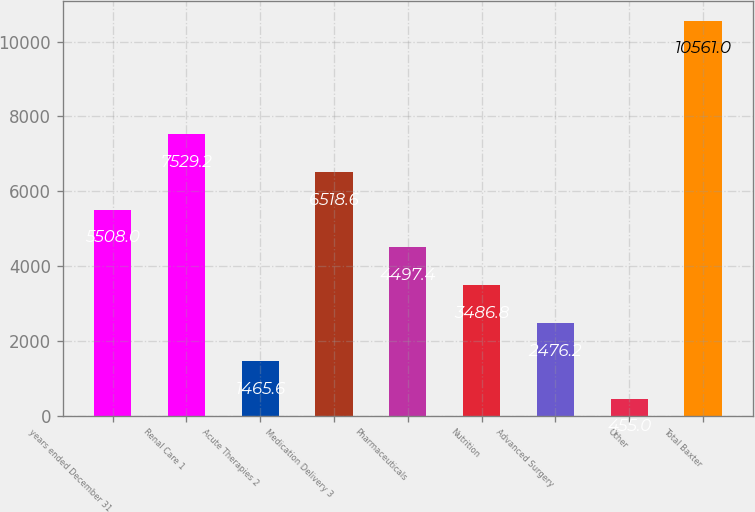Convert chart. <chart><loc_0><loc_0><loc_500><loc_500><bar_chart><fcel>years ended December 31<fcel>Renal Care 1<fcel>Acute Therapies 2<fcel>Medication Delivery 3<fcel>Pharmaceuticals<fcel>Nutrition<fcel>Advanced Surgery<fcel>Other<fcel>Total Baxter<nl><fcel>5508<fcel>7529.2<fcel>1465.6<fcel>6518.6<fcel>4497.4<fcel>3486.8<fcel>2476.2<fcel>455<fcel>10561<nl></chart> 